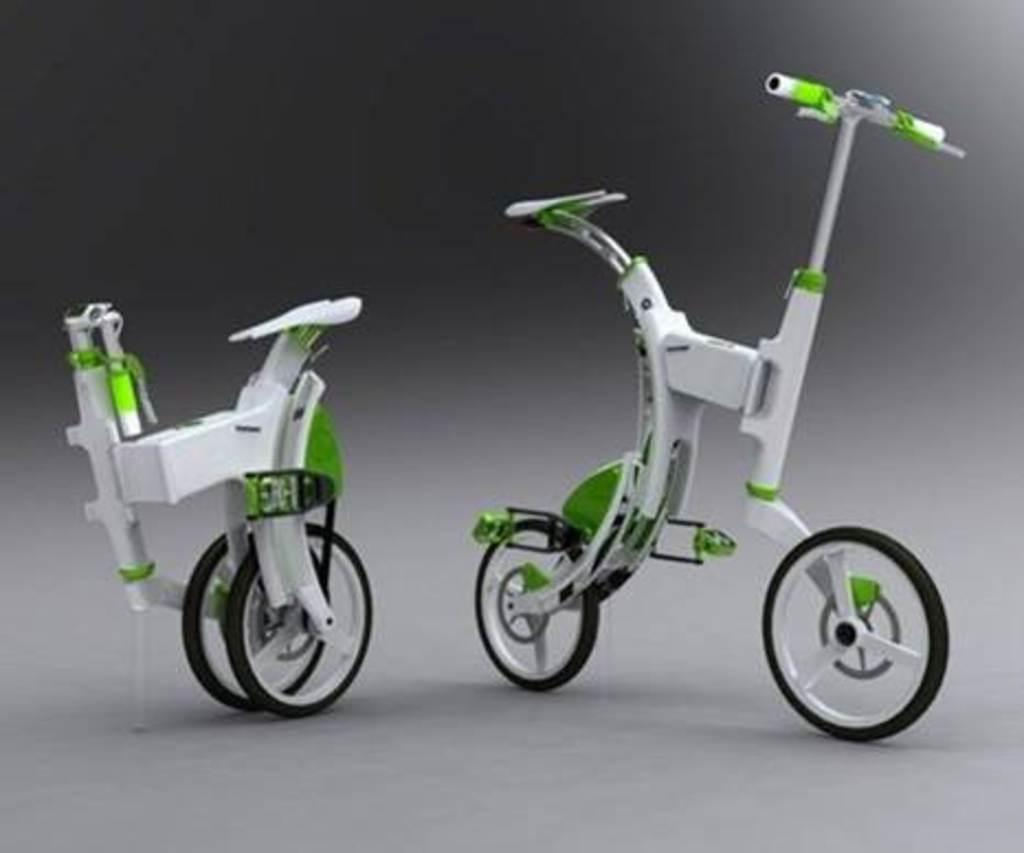What type of toys are present in the image? There are toy bicycles in the image. Can you describe the positioning of the toy bicycles? The toy bicycles are on a surface. What type of credit can be seen on the toy bicycles in the image? There is no credit or branding visible on the toy bicycles in the image. Can you tell me how many goats are present in the image? There are no goats present in the image; it features toy bicycles on a surface. 